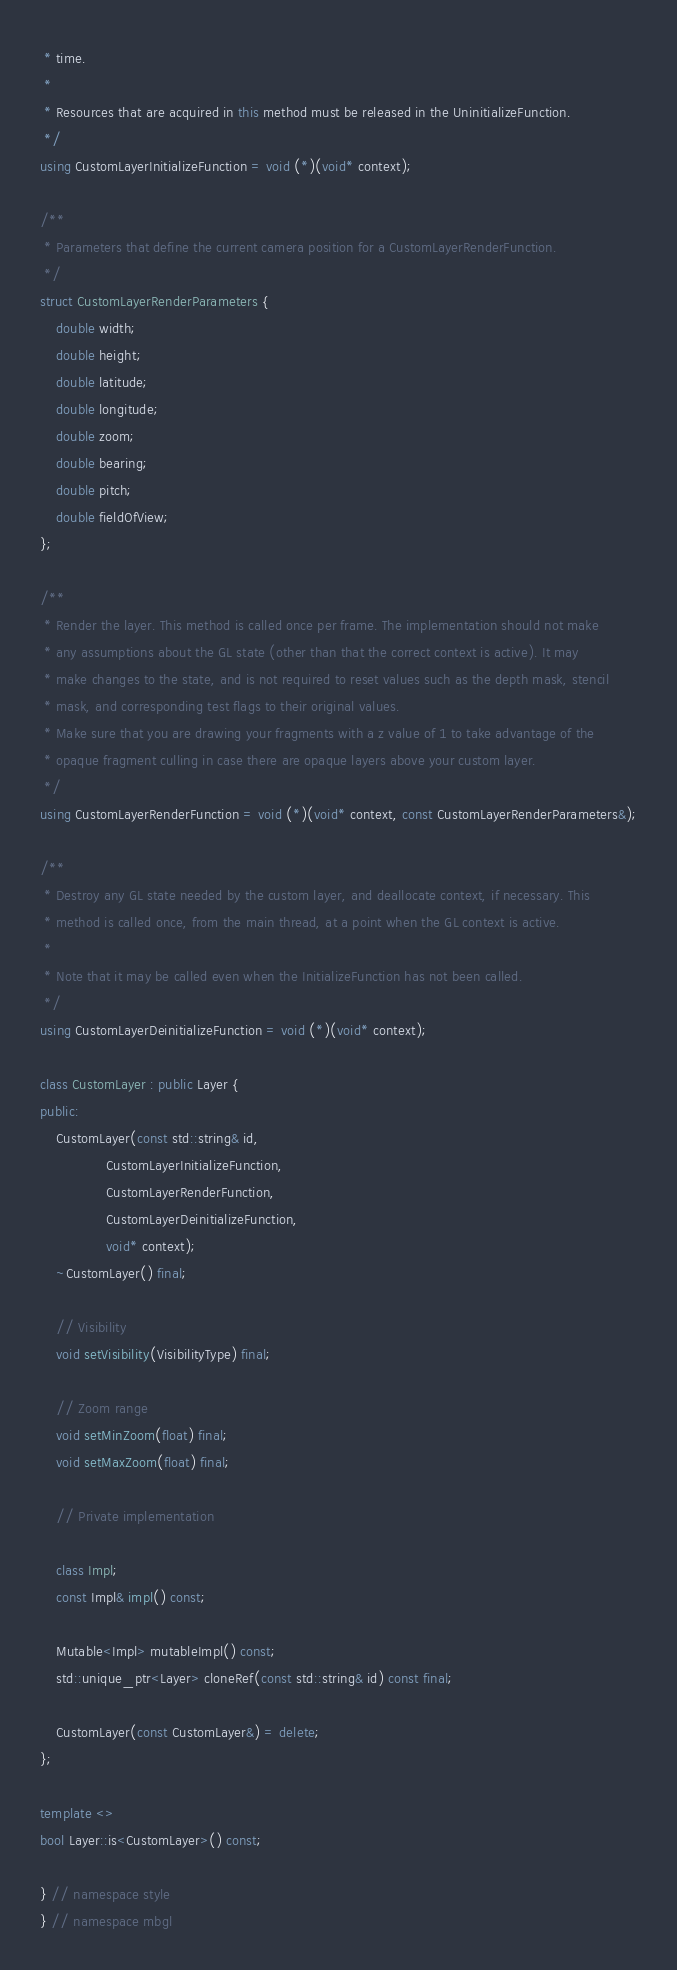Convert code to text. <code><loc_0><loc_0><loc_500><loc_500><_C++_> * time.
 *
 * Resources that are acquired in this method must be released in the UninitializeFunction.
 */
using CustomLayerInitializeFunction = void (*)(void* context);

/**
 * Parameters that define the current camera position for a CustomLayerRenderFunction.
 */
struct CustomLayerRenderParameters {
    double width;
    double height;
    double latitude;
    double longitude;
    double zoom;
    double bearing;
    double pitch;
    double fieldOfView;
};

/**
 * Render the layer. This method is called once per frame. The implementation should not make
 * any assumptions about the GL state (other than that the correct context is active). It may
 * make changes to the state, and is not required to reset values such as the depth mask, stencil
 * mask, and corresponding test flags to their original values.
 * Make sure that you are drawing your fragments with a z value of 1 to take advantage of the
 * opaque fragment culling in case there are opaque layers above your custom layer.
 */
using CustomLayerRenderFunction = void (*)(void* context, const CustomLayerRenderParameters&);

/**
 * Destroy any GL state needed by the custom layer, and deallocate context, if necessary. This
 * method is called once, from the main thread, at a point when the GL context is active.
 *
 * Note that it may be called even when the InitializeFunction has not been called.
 */
using CustomLayerDeinitializeFunction = void (*)(void* context);

class CustomLayer : public Layer {
public:
    CustomLayer(const std::string& id,
                CustomLayerInitializeFunction,
                CustomLayerRenderFunction,
                CustomLayerDeinitializeFunction,
                void* context);
    ~CustomLayer() final;

    // Visibility
    void setVisibility(VisibilityType) final;

    // Zoom range
    void setMinZoom(float) final;
    void setMaxZoom(float) final;

    // Private implementation

    class Impl;
    const Impl& impl() const;

    Mutable<Impl> mutableImpl() const;
    std::unique_ptr<Layer> cloneRef(const std::string& id) const final;

    CustomLayer(const CustomLayer&) = delete;
};

template <>
bool Layer::is<CustomLayer>() const;

} // namespace style
} // namespace mbgl
</code> 